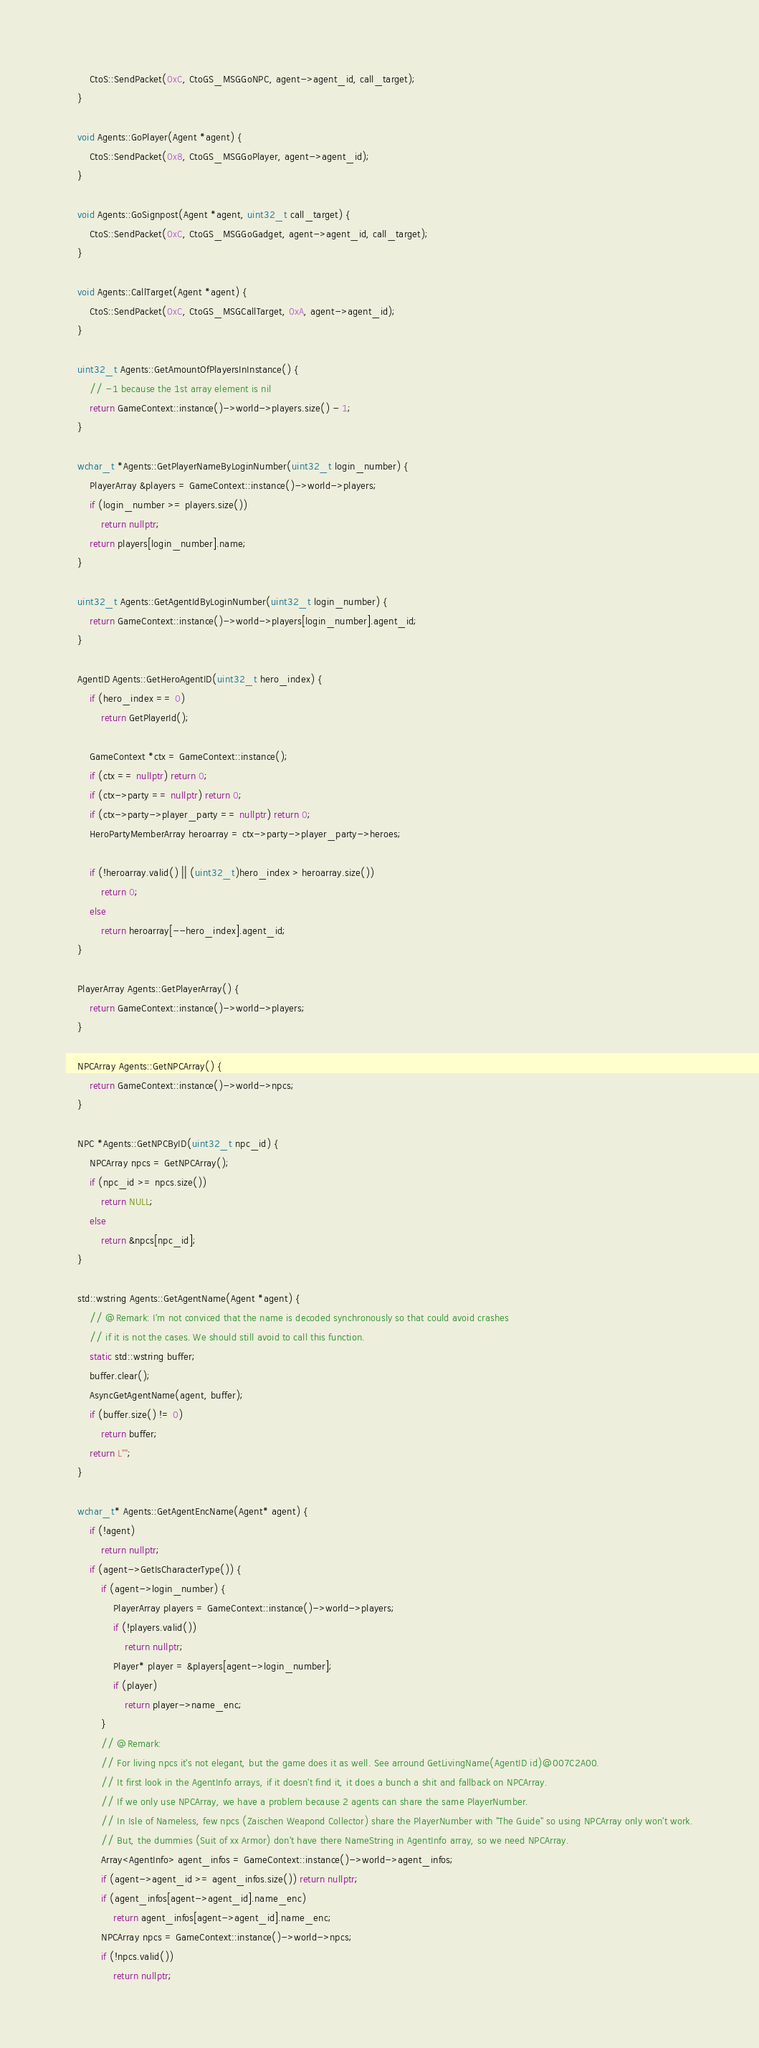Convert code to text. <code><loc_0><loc_0><loc_500><loc_500><_C++_>        CtoS::SendPacket(0xC, CtoGS_MSGGoNPC, agent->agent_id, call_target);
    }

    void Agents::GoPlayer(Agent *agent) {
        CtoS::SendPacket(0x8, CtoGS_MSGGoPlayer, agent->agent_id);
    }

    void Agents::GoSignpost(Agent *agent, uint32_t call_target) {
        CtoS::SendPacket(0xC, CtoGS_MSGGoGadget, agent->agent_id, call_target);
    }

    void Agents::CallTarget(Agent *agent) {
        CtoS::SendPacket(0xC, CtoGS_MSGCallTarget, 0xA, agent->agent_id);
    }

    uint32_t Agents::GetAmountOfPlayersInInstance() {
        // -1 because the 1st array element is nil
        return GameContext::instance()->world->players.size() - 1;
    }

    wchar_t *Agents::GetPlayerNameByLoginNumber(uint32_t login_number) {
        PlayerArray &players = GameContext::instance()->world->players;
        if (login_number >= players.size())
            return nullptr;
        return players[login_number].name;
    }

    uint32_t Agents::GetAgentIdByLoginNumber(uint32_t login_number) {
        return GameContext::instance()->world->players[login_number].agent_id;
    }

    AgentID Agents::GetHeroAgentID(uint32_t hero_index) {
        if (hero_index == 0)
            return GetPlayerId();

        GameContext *ctx = GameContext::instance();
        if (ctx == nullptr) return 0;
        if (ctx->party == nullptr) return 0;
        if (ctx->party->player_party == nullptr) return 0;
        HeroPartyMemberArray heroarray = ctx->party->player_party->heroes;

        if (!heroarray.valid() || (uint32_t)hero_index > heroarray.size())
            return 0;
        else
            return heroarray[--hero_index].agent_id;
    }

    PlayerArray Agents::GetPlayerArray() {
        return GameContext::instance()->world->players;
    }

    NPCArray Agents::GetNPCArray() {
        return GameContext::instance()->world->npcs;
    }

    NPC *Agents::GetNPCByID(uint32_t npc_id) {
        NPCArray npcs = GetNPCArray();
        if (npc_id >= npcs.size())
            return NULL;
        else
            return &npcs[npc_id];
    }

    std::wstring Agents::GetAgentName(Agent *agent) {
        // @Remark: I'm not conviced that the name is decoded synchronously so that could avoid crashes
        // if it is not the cases. We should still avoid to call this function.
        static std::wstring buffer;
        buffer.clear();
        AsyncGetAgentName(agent, buffer);
        if (buffer.size() != 0)
            return buffer;
        return L"";
    }

    wchar_t* Agents::GetAgentEncName(Agent* agent) {
        if (!agent) 
            return nullptr;
        if (agent->GetIsCharacterType()) {
            if (agent->login_number) {
                PlayerArray players = GameContext::instance()->world->players;
                if (!players.valid()) 
                    return nullptr;
                Player* player = &players[agent->login_number];
                if (player)
                    return player->name_enc;
            }
            // @Remark:
            // For living npcs it's not elegant, but the game does it as well. See arround GetLivingName(AgentID id)@007C2A00.
            // It first look in the AgentInfo arrays, if it doesn't find it, it does a bunch a shit and fallback on NPCArray.
            // If we only use NPCArray, we have a problem because 2 agents can share the same PlayerNumber.
            // In Isle of Nameless, few npcs (Zaischen Weapond Collector) share the PlayerNumber with "The Guide" so using NPCArray only won't work.
            // But, the dummies (Suit of xx Armor) don't have there NameString in AgentInfo array, so we need NPCArray.
            Array<AgentInfo> agent_infos = GameContext::instance()->world->agent_infos;
            if (agent->agent_id >= agent_infos.size()) return nullptr;
            if (agent_infos[agent->agent_id].name_enc)
                return agent_infos[agent->agent_id].name_enc;
            NPCArray npcs = GameContext::instance()->world->npcs;
            if (!npcs.valid()) 
                return nullptr;</code> 